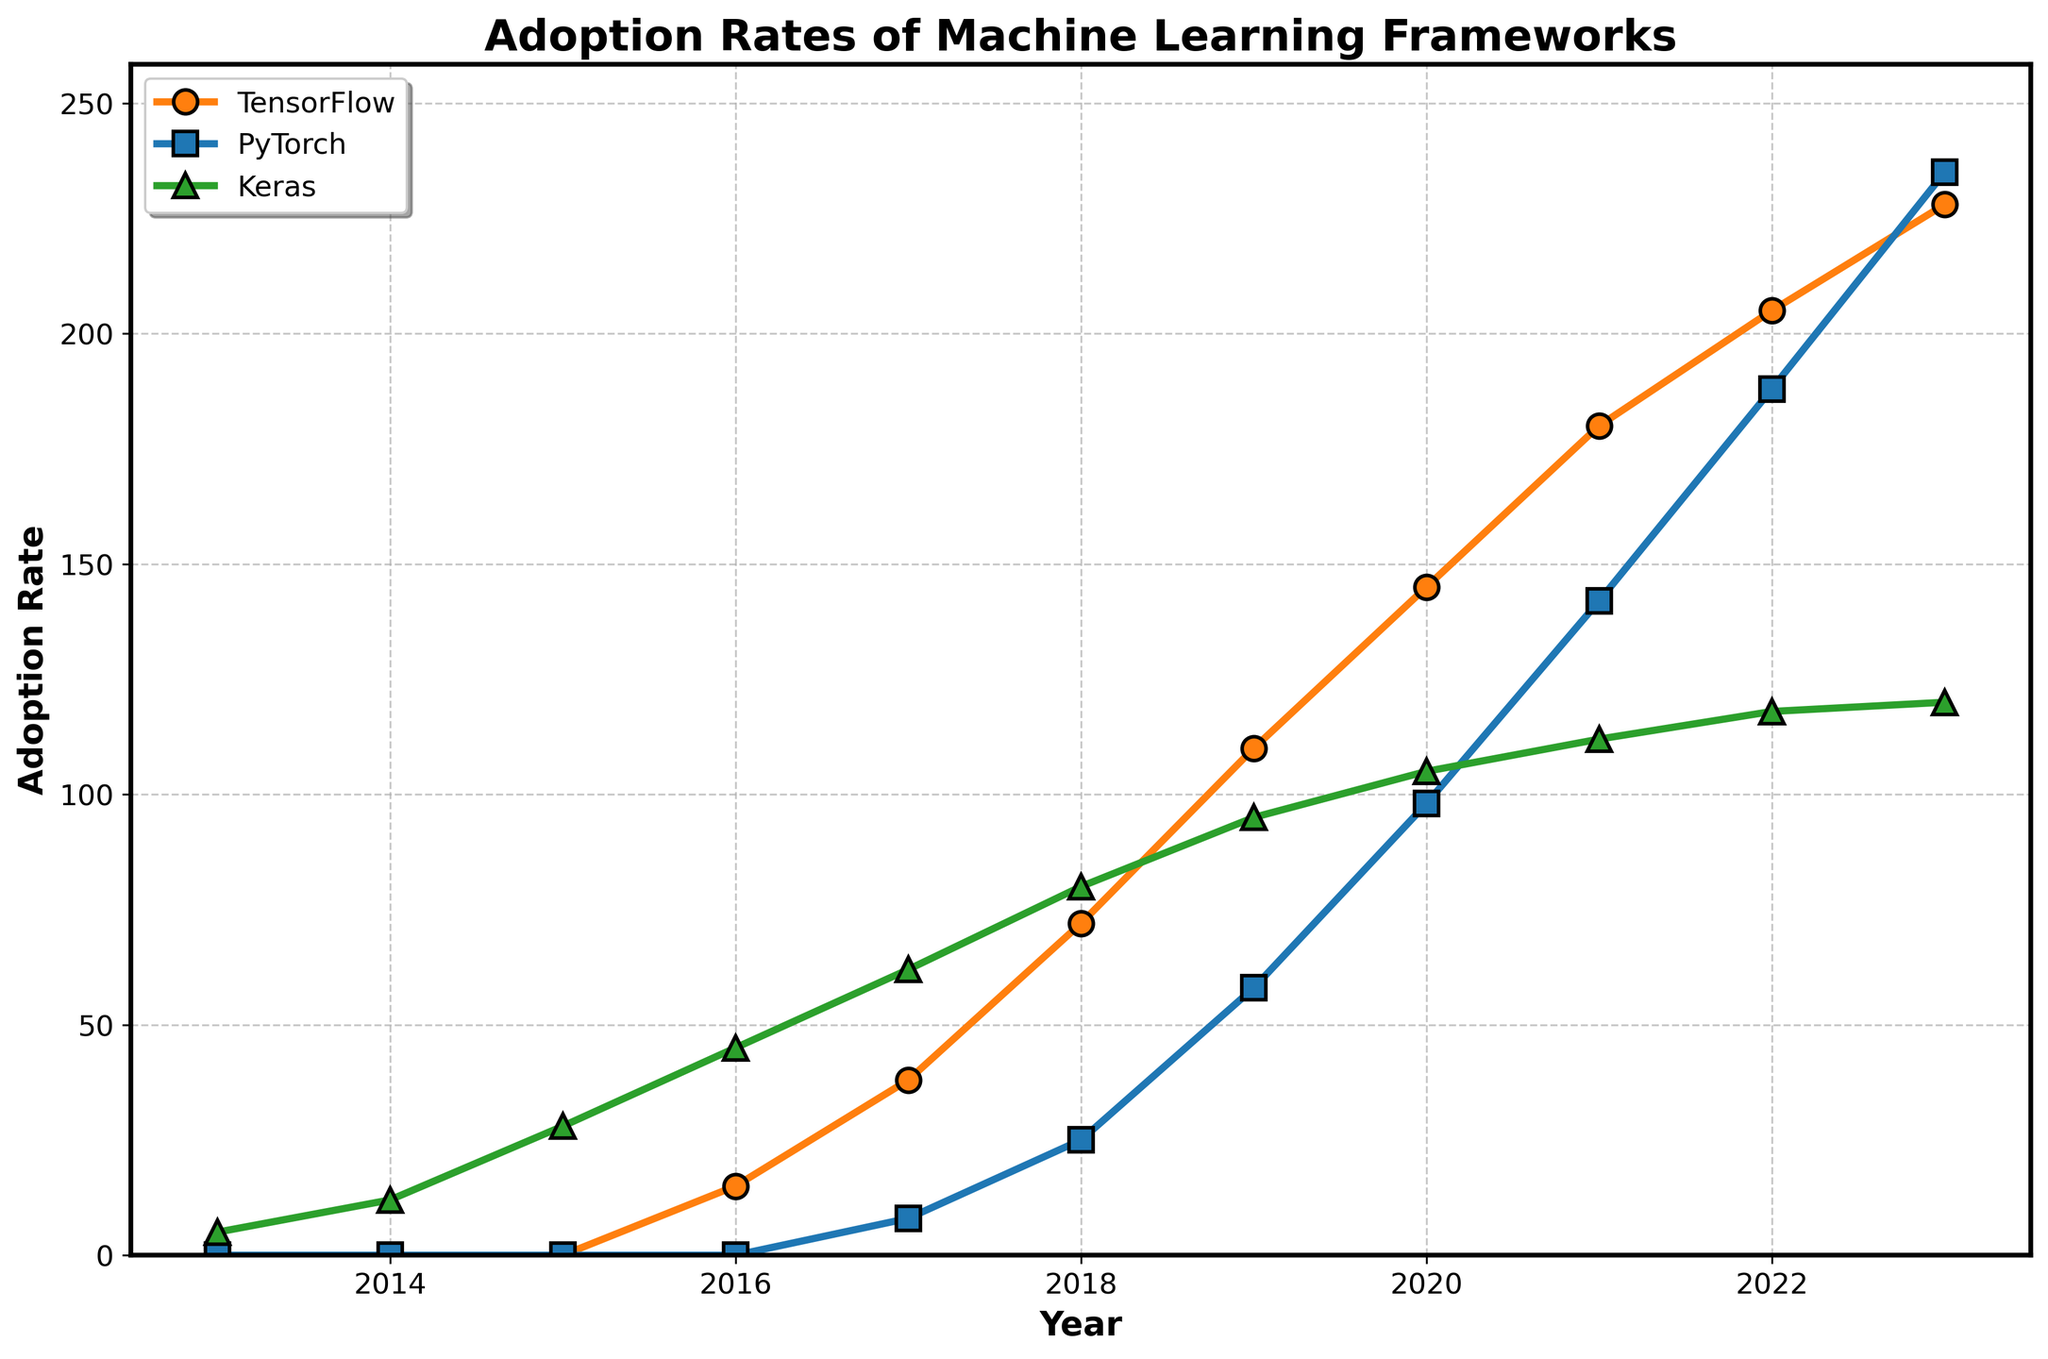What year did PyTorch adoption surpass TensorFlow? According to the figure, PyTorch adoption rates surpassed TensorFlow in the year 2023. Up until 2022, TensorFlow had a higher adoption rate, but in 2023, PyTorch adoption rate reached 235, whereas TensorFlow was at 228.
Answer: 2023 Which framework had the highest adoption rate in 2018? Referring to the data points in the figure for the year 2018, Keras had the highest adoption rate at 80. TensorFlow and PyTorch had lower adoption rates of 72 and 25 respectively.
Answer: Keras How much did the adoption rate of TensorFlow increase from 2016 to 2018? From the visual data, TensorFlow's adoption rate in 2016 was 15, and it increased to 72 by 2018. The increase can be calculated as 72 - 15 = 57.
Answer: 57 Compare the trends of TensorFlow and Keras adoption rates between 2017 and 2019. Observing the figure between 2017 and 2019, TensorFlow adoption rates increased significantly from 38 to 110, while Keras saw a smaller increase from 62 to 95. TensorFlow's adoption rate showed a steeper rise compared to Keras during this period.
Answer: TensorFlow increased more steeply What's the average adoption rate of Keras from 2016 to 2023? From the figure:
   - 2016: 45
   - 2017: 62
   - 2018: 80
   - 2019: 95
   - 2020: 105
   - 2021: 112
   - 2022: 118
   - 2023: 120
   Summing these values: 45 + 62 + 80 + 95 + 105 + 112 + 118 + 120 = 737.
   Dividing by the number of years (8) gives 737/8 ≈ 92.13.
Answer: 92.13 By how much did the adoption rate of PyTorch increase from 2020 to 2023? According to the figure, PyTorch's adoption rate in 2020 was 98 and in 2023 it was 235. The increase is calculated as 235 - 98 = 137.
Answer: 137 What is the difference in adoption rates between TensorFlow and Keras in 2021? In 2021, TensorFlow had an adoption rate of 180 and Keras had 112. The difference is 180 - 112 = 68.
Answer: 68 Which framework shows a consistently increasing adoption rate from 2016 to 2023? By examining the trend lines in the figure, both TensorFlow and PyTorch have consistently increasing adoption rates from 2016 to 2023, unlike Keras which plateaued around 2020.
Answer: TensorFlow and PyTorch 